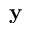Convert formula to latex. <formula><loc_0><loc_0><loc_500><loc_500>y</formula> 